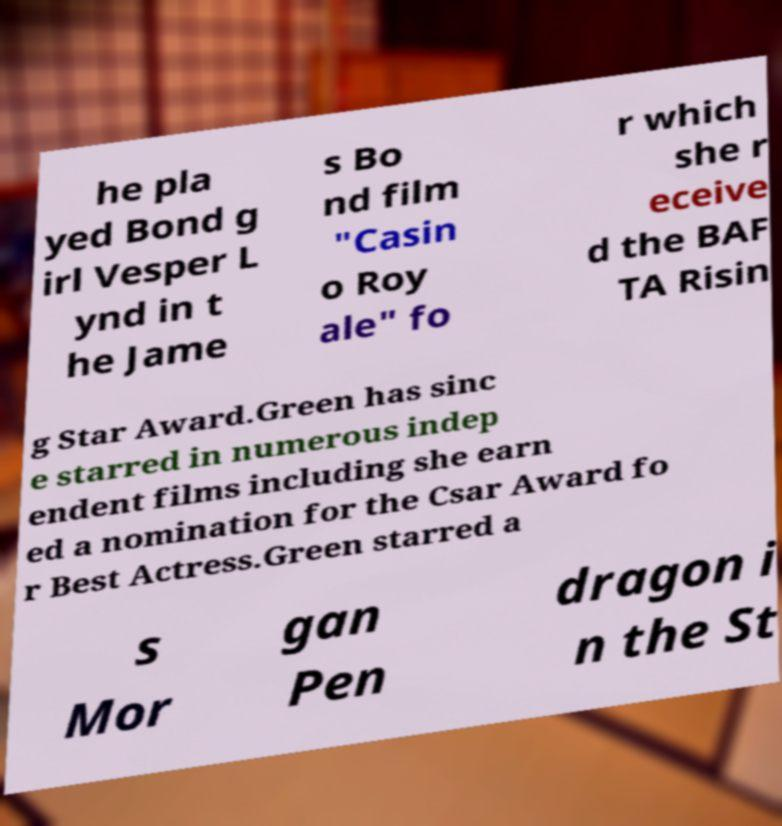Can you accurately transcribe the text from the provided image for me? he pla yed Bond g irl Vesper L ynd in t he Jame s Bo nd film "Casin o Roy ale" fo r which she r eceive d the BAF TA Risin g Star Award.Green has sinc e starred in numerous indep endent films including she earn ed a nomination for the Csar Award fo r Best Actress.Green starred a s Mor gan Pen dragon i n the St 